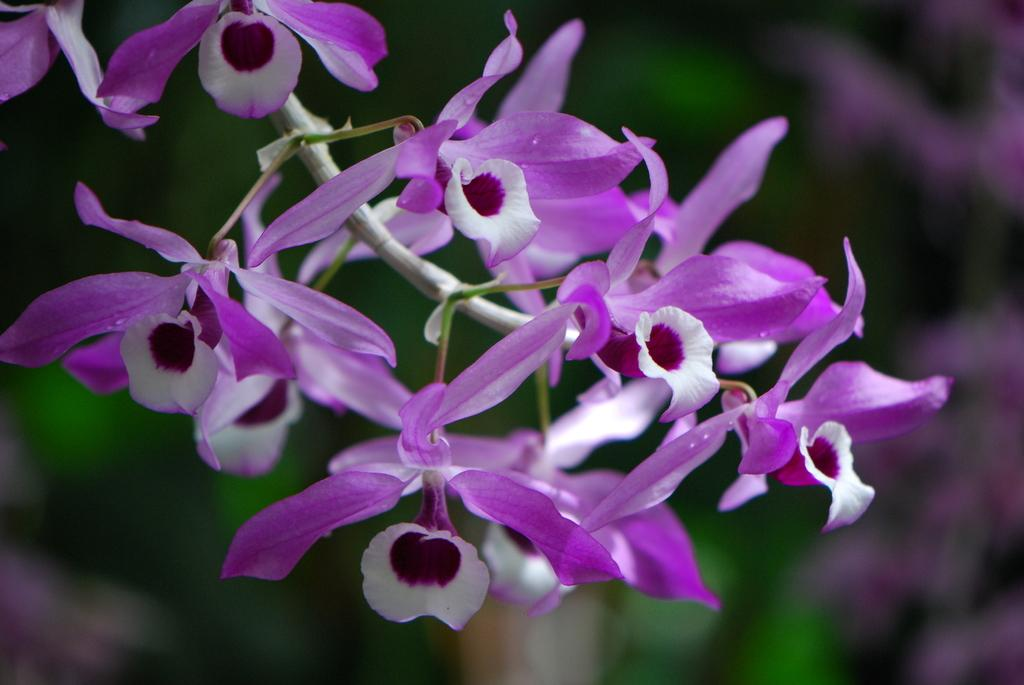What type of plants can be seen in the image? There are flowers in the image. Can you describe the background of the image? The background of the image is blurred. How many chairs are visible in the image? There are no chairs present in the image; it only features flowers and a blurred background. 